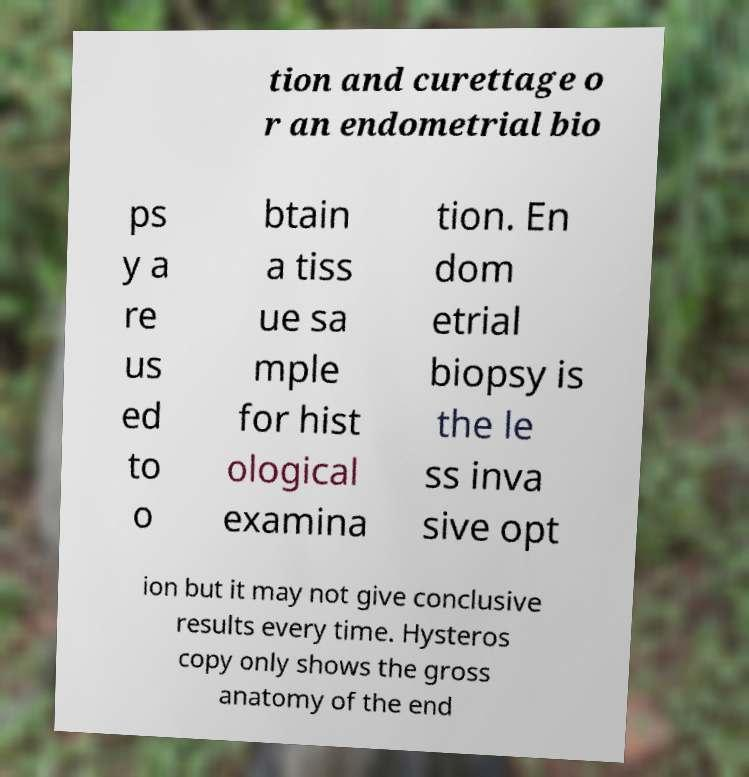I need the written content from this picture converted into text. Can you do that? tion and curettage o r an endometrial bio ps y a re us ed to o btain a tiss ue sa mple for hist ological examina tion. En dom etrial biopsy is the le ss inva sive opt ion but it may not give conclusive results every time. Hysteros copy only shows the gross anatomy of the end 